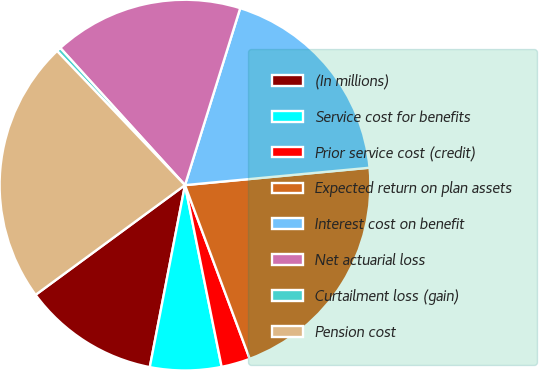Convert chart to OTSL. <chart><loc_0><loc_0><loc_500><loc_500><pie_chart><fcel>(In millions)<fcel>Service cost for benefits<fcel>Prior service cost (credit)<fcel>Expected return on plan assets<fcel>Interest cost on benefit<fcel>Net actuarial loss<fcel>Curtailment loss (gain)<fcel>Pension cost<nl><fcel>11.88%<fcel>6.21%<fcel>2.51%<fcel>20.82%<fcel>18.69%<fcel>16.56%<fcel>0.38%<fcel>22.96%<nl></chart> 